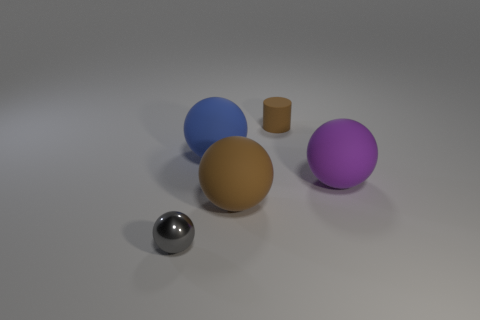Subtract 1 balls. How many balls are left? 3 Subtract all red spheres. Subtract all red cubes. How many spheres are left? 4 Add 4 shiny spheres. How many objects exist? 9 Subtract all balls. How many objects are left? 1 Subtract 0 gray cylinders. How many objects are left? 5 Subtract all large brown rubber cylinders. Subtract all purple rubber balls. How many objects are left? 4 Add 1 large spheres. How many large spheres are left? 4 Add 2 blue objects. How many blue objects exist? 3 